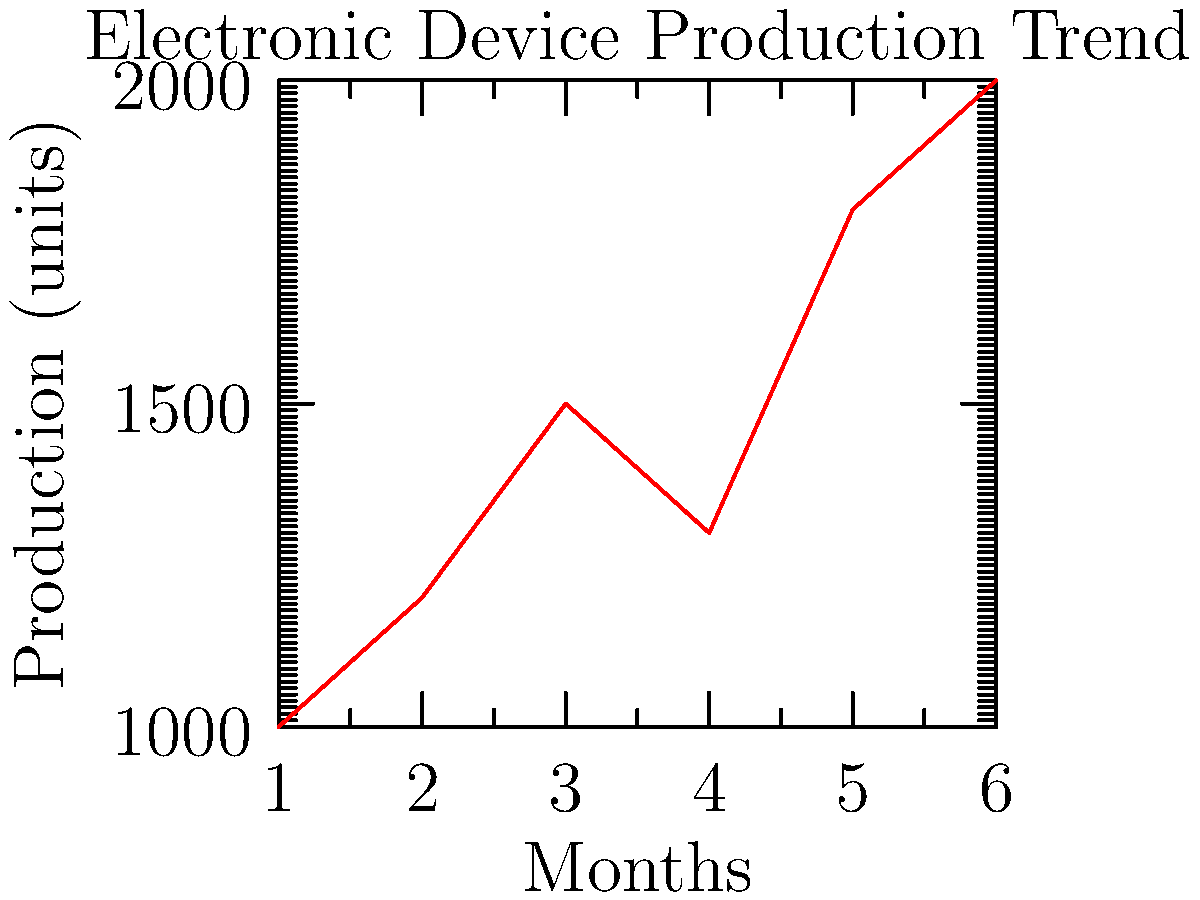Based on the line graph showing electronic device production trends over six months, what is the average monthly increase in production from the first month to the last month? To solve this problem, we need to follow these steps:

1. Identify the production values for the first and last months:
   First month (Month 1): 1000 units
   Last month (Month 6): 2000 units

2. Calculate the total increase in production:
   Total increase = Last month production - First month production
   Total increase = 2000 - 1000 = 1000 units

3. Calculate the number of intervals between the first and last month:
   Number of intervals = Last month - First month
   Number of intervals = 6 - 1 = 5 intervals

4. Calculate the average monthly increase:
   Average monthly increase = Total increase ÷ Number of intervals
   Average monthly increase = 1000 ÷ 5 = 200 units per month

Therefore, the average monthly increase in production from the first month to the last month is 200 units.
Answer: 200 units per month 